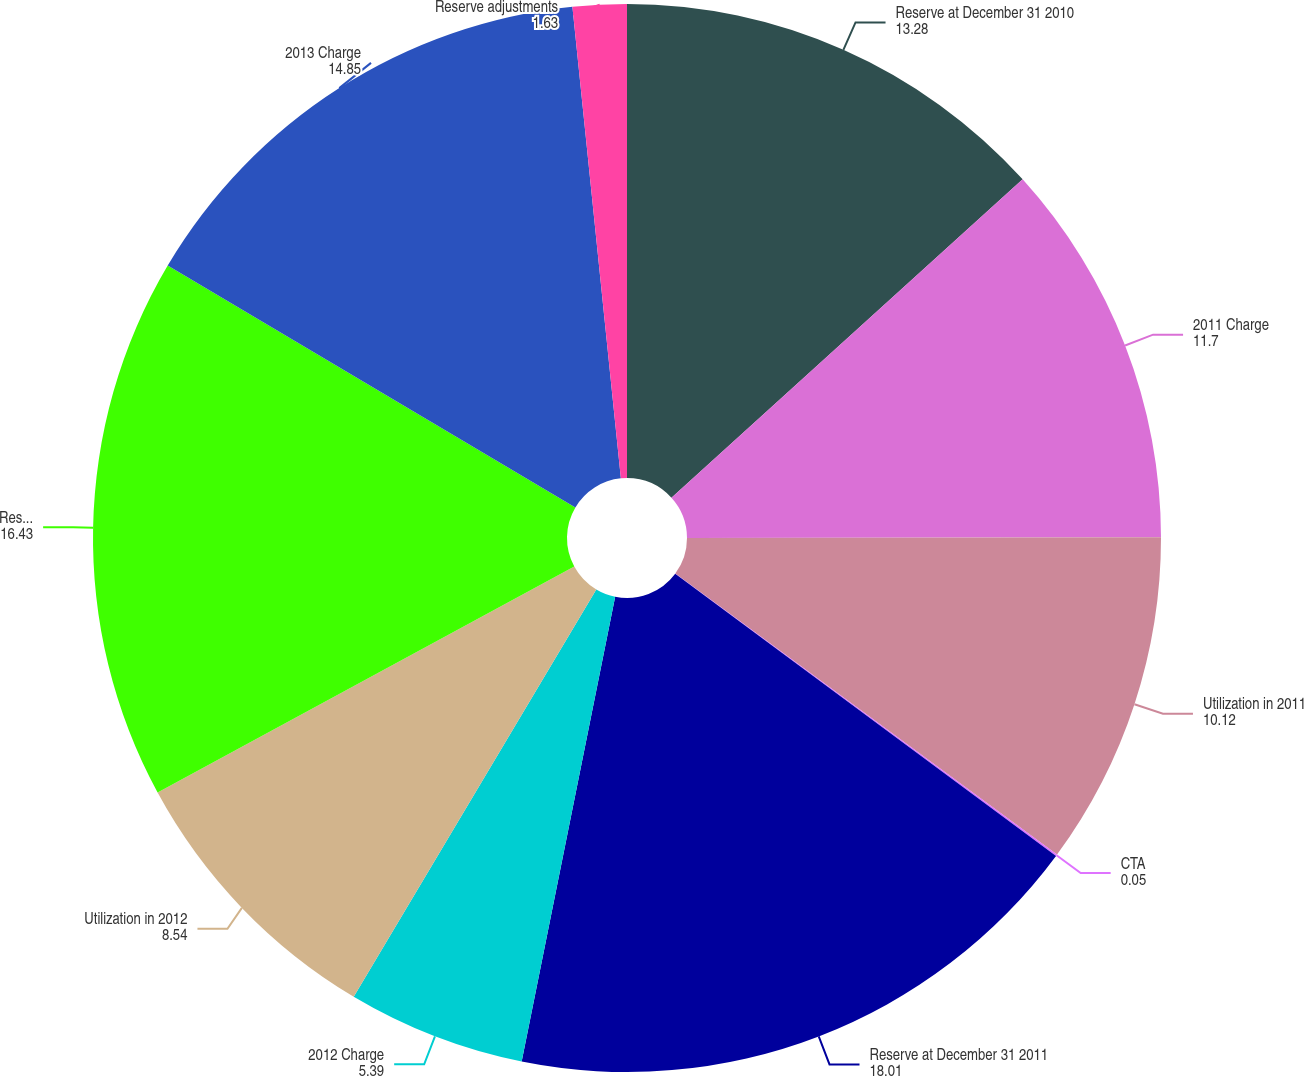<chart> <loc_0><loc_0><loc_500><loc_500><pie_chart><fcel>Reserve at December 31 2010<fcel>2011 Charge<fcel>Utilization in 2011<fcel>CTA<fcel>Reserve at December 31 2011<fcel>2012 Charge<fcel>Utilization in 2012<fcel>Reserve at December 31 2012<fcel>2013 Charge<fcel>Reserve adjustments<nl><fcel>13.28%<fcel>11.7%<fcel>10.12%<fcel>0.05%<fcel>18.01%<fcel>5.39%<fcel>8.54%<fcel>16.43%<fcel>14.85%<fcel>1.63%<nl></chart> 